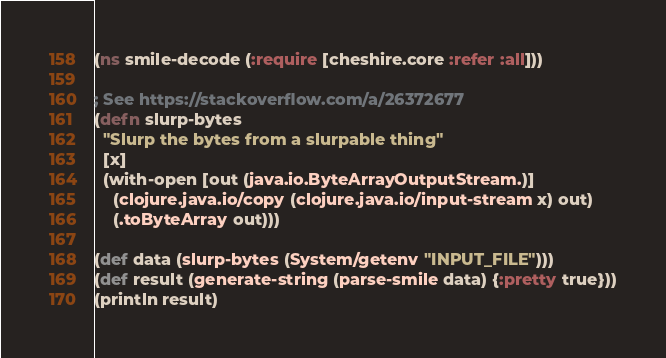<code> <loc_0><loc_0><loc_500><loc_500><_Clojure_>(ns smile-decode (:require [cheshire.core :refer :all]))

; See https://stackoverflow.com/a/26372677
(defn slurp-bytes
  "Slurp the bytes from a slurpable thing"
  [x]
  (with-open [out (java.io.ByteArrayOutputStream.)]
    (clojure.java.io/copy (clojure.java.io/input-stream x) out)
    (.toByteArray out)))

(def data (slurp-bytes (System/getenv "INPUT_FILE")))
(def result (generate-string (parse-smile data) {:pretty true}))
(println result)
</code> 